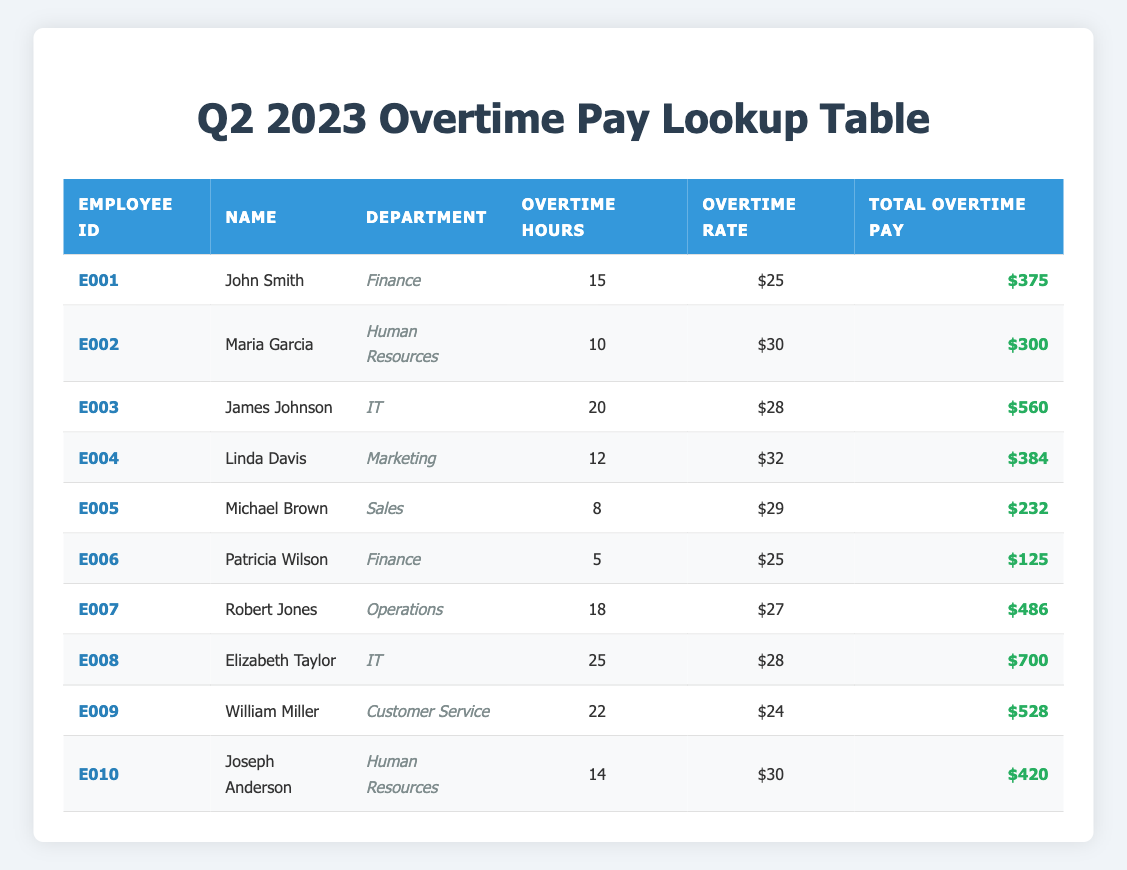What is the total overtime pay for John Smith? John Smith's total overtime pay is listed in the table under the "Total Overtime Pay" column. It shows $375 beside his name.
Answer: $375 How many overtime hours did Elizabeth Taylor work? In the table, the number of overtime hours for Elizabeth Taylor can be found in the "Overtime Hours" column. It indicates that she worked 25 hours.
Answer: 25 Which department had the highest total overtime pay? To find the department with the highest total overtime pay, we compare the total overtime pay of all employees in each department. The highest total is $700 for the IT department (Elizabeth Taylor).
Answer: IT What is the average overtime pay for all employees? To calculate the average, we first sum the total overtime pay: 375 + 300 + 560 + 384 + 232 + 125 + 486 + 700 + 528 + 420 = 3780. Then, we divide by the number of employees, which is 10: 3780 / 10 = 378.
Answer: 378 Did Maria Garcia earn more than Michael Brown in total overtime pay? Maria Garcia's total overtime pay is $300, while Michael Brown's is $232. Comparing these values, we see that $300 is greater than $232, so the answer is yes.
Answer: Yes How many overtime hours did employees in the Finance department work in total? The overtime hours for John Smith (15 hours) and Patricia Wilson (5 hours) are found in the table. Summing these gives a total of 15 + 5 = 20 hours worked by the Finance department.
Answer: 20 Is the overtime rate for Robert Jones higher than that for John Smith? Robert Jones has an overtime rate of $27, while John Smith has an overtime rate of $25. Since $27 is greater than $25, the answer is yes.
Answer: Yes What is the difference in total overtime pay between the highest and lowest paid employees? The highest total overtime pay is $700 (Elizabeth Taylor) and the lowest is $125 (Patricia Wilson). The difference is calculated as 700 - 125 = 575.
Answer: 575 Which employee worked the most overtime hours? By examining the "Overtime Hours" column, we find that Elizabeth Taylor worked the most at 25 hours, more than any other employee.
Answer: Elizabeth Taylor 